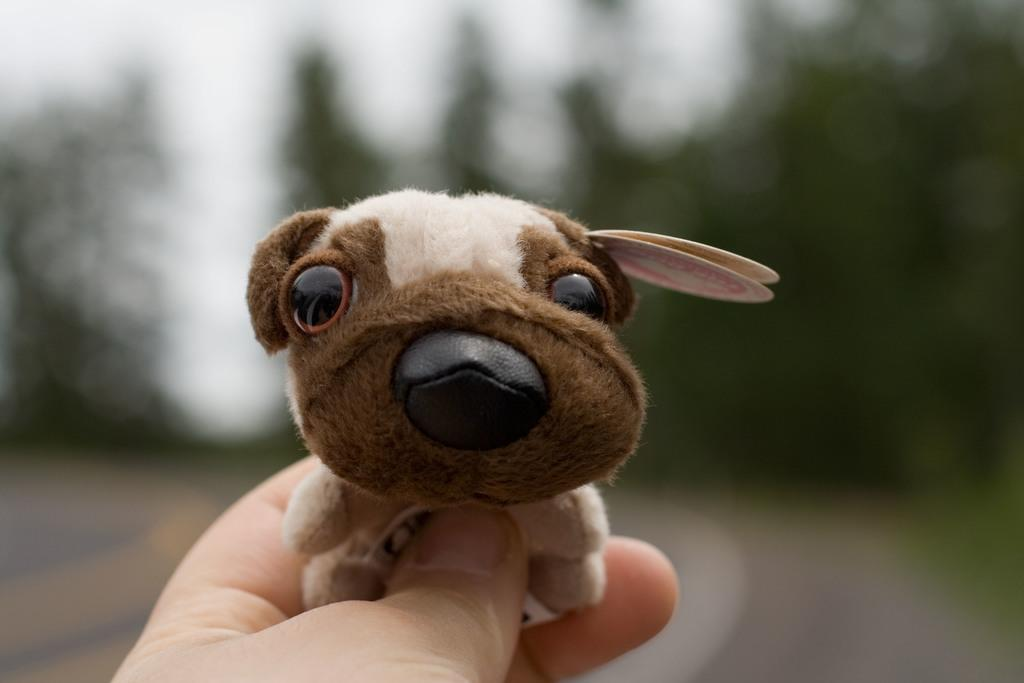What is being held by the hand in the image? There is a hand holding a doll in the image. Can you describe the background of the image? The background of the image is blurred. How many dimes are visible on the chair in the image? There is no chair or dimes present in the image. What type of kitten can be seen playing with the doll in the image? There is no kitten present in the image, and the doll is being held by a hand, not played with by a kitten. 